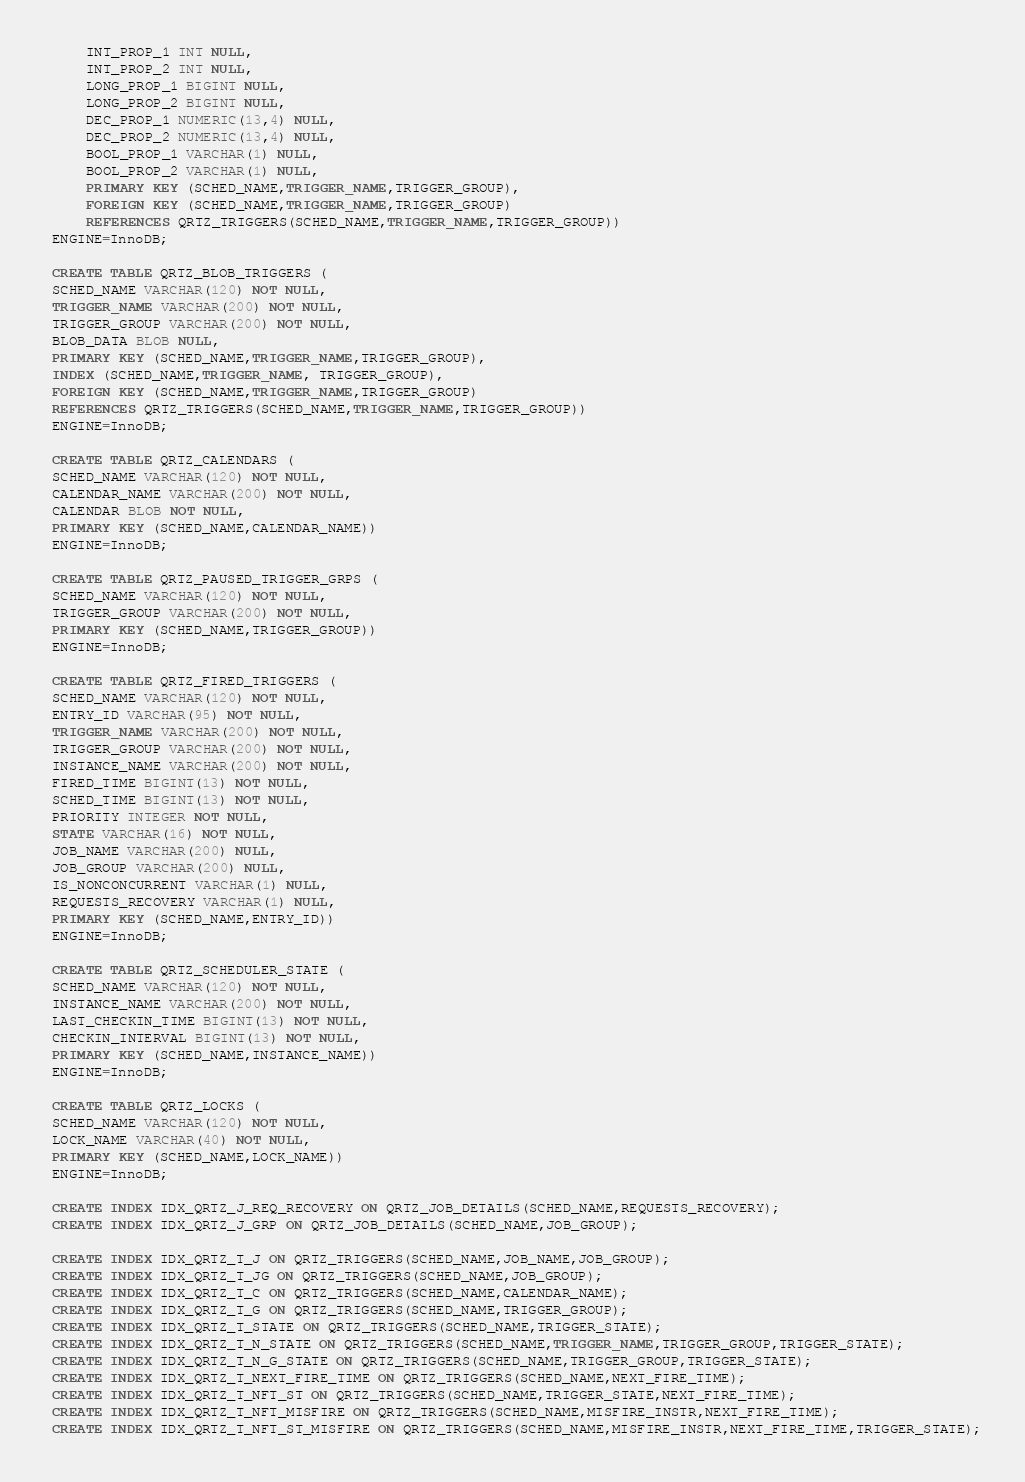Convert code to text. <code><loc_0><loc_0><loc_500><loc_500><_SQL_>     INT_PROP_1 INT NULL,
     INT_PROP_2 INT NULL,
     LONG_PROP_1 BIGINT NULL,
     LONG_PROP_2 BIGINT NULL,
     DEC_PROP_1 NUMERIC(13,4) NULL,
     DEC_PROP_2 NUMERIC(13,4) NULL,
     BOOL_PROP_1 VARCHAR(1) NULL,
     BOOL_PROP_2 VARCHAR(1) NULL,
     PRIMARY KEY (SCHED_NAME,TRIGGER_NAME,TRIGGER_GROUP),
     FOREIGN KEY (SCHED_NAME,TRIGGER_NAME,TRIGGER_GROUP) 
     REFERENCES QRTZ_TRIGGERS(SCHED_NAME,TRIGGER_NAME,TRIGGER_GROUP))
 ENGINE=InnoDB;
 
 CREATE TABLE QRTZ_BLOB_TRIGGERS (
 SCHED_NAME VARCHAR(120) NOT NULL,
 TRIGGER_NAME VARCHAR(200) NOT NULL,
 TRIGGER_GROUP VARCHAR(200) NOT NULL,
 BLOB_DATA BLOB NULL,
 PRIMARY KEY (SCHED_NAME,TRIGGER_NAME,TRIGGER_GROUP),
 INDEX (SCHED_NAME,TRIGGER_NAME, TRIGGER_GROUP),
 FOREIGN KEY (SCHED_NAME,TRIGGER_NAME,TRIGGER_GROUP)
 REFERENCES QRTZ_TRIGGERS(SCHED_NAME,TRIGGER_NAME,TRIGGER_GROUP))
 ENGINE=InnoDB;
 
 CREATE TABLE QRTZ_CALENDARS (
 SCHED_NAME VARCHAR(120) NOT NULL,
 CALENDAR_NAME VARCHAR(200) NOT NULL,
 CALENDAR BLOB NOT NULL,
 PRIMARY KEY (SCHED_NAME,CALENDAR_NAME))
 ENGINE=InnoDB;
 
 CREATE TABLE QRTZ_PAUSED_TRIGGER_GRPS (
 SCHED_NAME VARCHAR(120) NOT NULL,
 TRIGGER_GROUP VARCHAR(200) NOT NULL,
 PRIMARY KEY (SCHED_NAME,TRIGGER_GROUP))
 ENGINE=InnoDB;
 
 CREATE TABLE QRTZ_FIRED_TRIGGERS (
 SCHED_NAME VARCHAR(120) NOT NULL,
 ENTRY_ID VARCHAR(95) NOT NULL,
 TRIGGER_NAME VARCHAR(200) NOT NULL,
 TRIGGER_GROUP VARCHAR(200) NOT NULL,
 INSTANCE_NAME VARCHAR(200) NOT NULL,
 FIRED_TIME BIGINT(13) NOT NULL,
 SCHED_TIME BIGINT(13) NOT NULL,
 PRIORITY INTEGER NOT NULL,
 STATE VARCHAR(16) NOT NULL,
 JOB_NAME VARCHAR(200) NULL,
 JOB_GROUP VARCHAR(200) NULL,
 IS_NONCONCURRENT VARCHAR(1) NULL,
 REQUESTS_RECOVERY VARCHAR(1) NULL,
 PRIMARY KEY (SCHED_NAME,ENTRY_ID))
 ENGINE=InnoDB;
 
 CREATE TABLE QRTZ_SCHEDULER_STATE (
 SCHED_NAME VARCHAR(120) NOT NULL,
 INSTANCE_NAME VARCHAR(200) NOT NULL,
 LAST_CHECKIN_TIME BIGINT(13) NOT NULL,
 CHECKIN_INTERVAL BIGINT(13) NOT NULL,
 PRIMARY KEY (SCHED_NAME,INSTANCE_NAME))
 ENGINE=InnoDB;
 
 CREATE TABLE QRTZ_LOCKS (
 SCHED_NAME VARCHAR(120) NOT NULL,
 LOCK_NAME VARCHAR(40) NOT NULL,
 PRIMARY KEY (SCHED_NAME,LOCK_NAME))
 ENGINE=InnoDB;
 
 CREATE INDEX IDX_QRTZ_J_REQ_RECOVERY ON QRTZ_JOB_DETAILS(SCHED_NAME,REQUESTS_RECOVERY);
 CREATE INDEX IDX_QRTZ_J_GRP ON QRTZ_JOB_DETAILS(SCHED_NAME,JOB_GROUP);
 
 CREATE INDEX IDX_QRTZ_T_J ON QRTZ_TRIGGERS(SCHED_NAME,JOB_NAME,JOB_GROUP);
 CREATE INDEX IDX_QRTZ_T_JG ON QRTZ_TRIGGERS(SCHED_NAME,JOB_GROUP);
 CREATE INDEX IDX_QRTZ_T_C ON QRTZ_TRIGGERS(SCHED_NAME,CALENDAR_NAME);
 CREATE INDEX IDX_QRTZ_T_G ON QRTZ_TRIGGERS(SCHED_NAME,TRIGGER_GROUP);
 CREATE INDEX IDX_QRTZ_T_STATE ON QRTZ_TRIGGERS(SCHED_NAME,TRIGGER_STATE);
 CREATE INDEX IDX_QRTZ_T_N_STATE ON QRTZ_TRIGGERS(SCHED_NAME,TRIGGER_NAME,TRIGGER_GROUP,TRIGGER_STATE);
 CREATE INDEX IDX_QRTZ_T_N_G_STATE ON QRTZ_TRIGGERS(SCHED_NAME,TRIGGER_GROUP,TRIGGER_STATE);
 CREATE INDEX IDX_QRTZ_T_NEXT_FIRE_TIME ON QRTZ_TRIGGERS(SCHED_NAME,NEXT_FIRE_TIME);
 CREATE INDEX IDX_QRTZ_T_NFT_ST ON QRTZ_TRIGGERS(SCHED_NAME,TRIGGER_STATE,NEXT_FIRE_TIME);
 CREATE INDEX IDX_QRTZ_T_NFT_MISFIRE ON QRTZ_TRIGGERS(SCHED_NAME,MISFIRE_INSTR,NEXT_FIRE_TIME);
 CREATE INDEX IDX_QRTZ_T_NFT_ST_MISFIRE ON QRTZ_TRIGGERS(SCHED_NAME,MISFIRE_INSTR,NEXT_FIRE_TIME,TRIGGER_STATE);</code> 